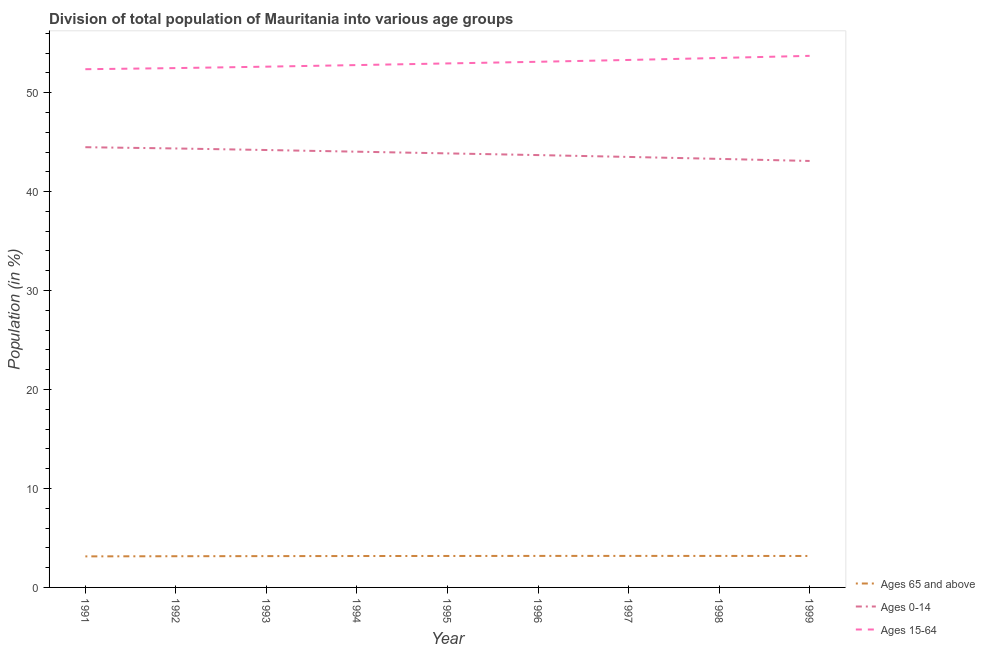Does the line corresponding to percentage of population within the age-group 0-14 intersect with the line corresponding to percentage of population within the age-group 15-64?
Offer a terse response. No. What is the percentage of population within the age-group 0-14 in 1999?
Provide a short and direct response. 43.1. Across all years, what is the maximum percentage of population within the age-group 15-64?
Your answer should be compact. 53.72. Across all years, what is the minimum percentage of population within the age-group 0-14?
Offer a very short reply. 43.1. In which year was the percentage of population within the age-group 0-14 maximum?
Provide a succinct answer. 1991. In which year was the percentage of population within the age-group of 65 and above minimum?
Provide a succinct answer. 1991. What is the total percentage of population within the age-group 15-64 in the graph?
Your answer should be compact. 476.89. What is the difference between the percentage of population within the age-group 15-64 in 1993 and that in 1995?
Give a very brief answer. -0.33. What is the difference between the percentage of population within the age-group of 65 and above in 1997 and the percentage of population within the age-group 15-64 in 1999?
Provide a succinct answer. -50.54. What is the average percentage of population within the age-group of 65 and above per year?
Offer a very short reply. 3.17. In the year 1999, what is the difference between the percentage of population within the age-group of 65 and above and percentage of population within the age-group 0-14?
Provide a succinct answer. -39.92. What is the ratio of the percentage of population within the age-group of 65 and above in 1992 to that in 1995?
Your answer should be compact. 0.99. Is the difference between the percentage of population within the age-group 15-64 in 1991 and 1992 greater than the difference between the percentage of population within the age-group 0-14 in 1991 and 1992?
Offer a very short reply. No. What is the difference between the highest and the second highest percentage of population within the age-group 15-64?
Provide a short and direct response. 0.21. What is the difference between the highest and the lowest percentage of population within the age-group of 65 and above?
Provide a short and direct response. 0.05. In how many years, is the percentage of population within the age-group of 65 and above greater than the average percentage of population within the age-group of 65 and above taken over all years?
Offer a very short reply. 6. Is the sum of the percentage of population within the age-group 0-14 in 1998 and 1999 greater than the maximum percentage of population within the age-group 15-64 across all years?
Offer a very short reply. Yes. How many lines are there?
Provide a succinct answer. 3. How many years are there in the graph?
Offer a very short reply. 9. What is the difference between two consecutive major ticks on the Y-axis?
Ensure brevity in your answer.  10. Does the graph contain grids?
Give a very brief answer. No. Where does the legend appear in the graph?
Your answer should be very brief. Bottom right. How many legend labels are there?
Your answer should be compact. 3. What is the title of the graph?
Your answer should be compact. Division of total population of Mauritania into various age groups
. What is the label or title of the X-axis?
Your response must be concise. Year. What is the label or title of the Y-axis?
Give a very brief answer. Population (in %). What is the Population (in %) in Ages 65 and above in 1991?
Provide a succinct answer. 3.14. What is the Population (in %) of Ages 0-14 in 1991?
Your answer should be compact. 44.49. What is the Population (in %) of Ages 15-64 in 1991?
Your answer should be compact. 52.37. What is the Population (in %) in Ages 65 and above in 1992?
Your answer should be very brief. 3.15. What is the Population (in %) in Ages 0-14 in 1992?
Your answer should be compact. 44.36. What is the Population (in %) of Ages 15-64 in 1992?
Provide a short and direct response. 52.48. What is the Population (in %) in Ages 65 and above in 1993?
Keep it short and to the point. 3.17. What is the Population (in %) in Ages 0-14 in 1993?
Your answer should be very brief. 44.21. What is the Population (in %) of Ages 15-64 in 1993?
Offer a very short reply. 52.63. What is the Population (in %) in Ages 65 and above in 1994?
Make the answer very short. 3.17. What is the Population (in %) in Ages 0-14 in 1994?
Keep it short and to the point. 44.04. What is the Population (in %) of Ages 15-64 in 1994?
Your response must be concise. 52.79. What is the Population (in %) in Ages 65 and above in 1995?
Give a very brief answer. 3.18. What is the Population (in %) of Ages 0-14 in 1995?
Your answer should be very brief. 43.86. What is the Population (in %) of Ages 15-64 in 1995?
Your answer should be very brief. 52.96. What is the Population (in %) in Ages 65 and above in 1996?
Offer a very short reply. 3.18. What is the Population (in %) of Ages 0-14 in 1996?
Keep it short and to the point. 43.69. What is the Population (in %) in Ages 15-64 in 1996?
Your answer should be compact. 53.12. What is the Population (in %) in Ages 65 and above in 1997?
Provide a succinct answer. 3.19. What is the Population (in %) in Ages 0-14 in 1997?
Ensure brevity in your answer.  43.51. What is the Population (in %) of Ages 15-64 in 1997?
Keep it short and to the point. 53.31. What is the Population (in %) in Ages 65 and above in 1998?
Your response must be concise. 3.18. What is the Population (in %) of Ages 0-14 in 1998?
Give a very brief answer. 43.31. What is the Population (in %) in Ages 15-64 in 1998?
Keep it short and to the point. 53.51. What is the Population (in %) of Ages 65 and above in 1999?
Provide a succinct answer. 3.18. What is the Population (in %) in Ages 0-14 in 1999?
Give a very brief answer. 43.1. What is the Population (in %) of Ages 15-64 in 1999?
Your response must be concise. 53.72. Across all years, what is the maximum Population (in %) in Ages 65 and above?
Ensure brevity in your answer.  3.19. Across all years, what is the maximum Population (in %) of Ages 0-14?
Your answer should be very brief. 44.49. Across all years, what is the maximum Population (in %) of Ages 15-64?
Make the answer very short. 53.72. Across all years, what is the minimum Population (in %) in Ages 65 and above?
Your answer should be very brief. 3.14. Across all years, what is the minimum Population (in %) in Ages 0-14?
Provide a succinct answer. 43.1. Across all years, what is the minimum Population (in %) of Ages 15-64?
Your answer should be compact. 52.37. What is the total Population (in %) of Ages 65 and above in the graph?
Keep it short and to the point. 28.54. What is the total Population (in %) of Ages 0-14 in the graph?
Offer a terse response. 394.57. What is the total Population (in %) of Ages 15-64 in the graph?
Offer a terse response. 476.89. What is the difference between the Population (in %) of Ages 65 and above in 1991 and that in 1992?
Provide a succinct answer. -0.01. What is the difference between the Population (in %) of Ages 0-14 in 1991 and that in 1992?
Provide a succinct answer. 0.13. What is the difference between the Population (in %) in Ages 15-64 in 1991 and that in 1992?
Give a very brief answer. -0.11. What is the difference between the Population (in %) of Ages 65 and above in 1991 and that in 1993?
Offer a terse response. -0.03. What is the difference between the Population (in %) of Ages 0-14 in 1991 and that in 1993?
Your answer should be very brief. 0.28. What is the difference between the Population (in %) in Ages 15-64 in 1991 and that in 1993?
Provide a succinct answer. -0.26. What is the difference between the Population (in %) of Ages 65 and above in 1991 and that in 1994?
Make the answer very short. -0.04. What is the difference between the Population (in %) of Ages 0-14 in 1991 and that in 1994?
Make the answer very short. 0.45. What is the difference between the Population (in %) of Ages 15-64 in 1991 and that in 1994?
Provide a short and direct response. -0.42. What is the difference between the Population (in %) in Ages 65 and above in 1991 and that in 1995?
Offer a very short reply. -0.04. What is the difference between the Population (in %) of Ages 0-14 in 1991 and that in 1995?
Your response must be concise. 0.63. What is the difference between the Population (in %) in Ages 15-64 in 1991 and that in 1995?
Provide a short and direct response. -0.58. What is the difference between the Population (in %) in Ages 65 and above in 1991 and that in 1996?
Offer a terse response. -0.05. What is the difference between the Population (in %) of Ages 0-14 in 1991 and that in 1996?
Your response must be concise. 0.8. What is the difference between the Population (in %) in Ages 15-64 in 1991 and that in 1996?
Give a very brief answer. -0.75. What is the difference between the Population (in %) in Ages 65 and above in 1991 and that in 1997?
Offer a terse response. -0.05. What is the difference between the Population (in %) in Ages 0-14 in 1991 and that in 1997?
Your response must be concise. 0.98. What is the difference between the Population (in %) of Ages 15-64 in 1991 and that in 1997?
Give a very brief answer. -0.94. What is the difference between the Population (in %) of Ages 65 and above in 1991 and that in 1998?
Your answer should be compact. -0.05. What is the difference between the Population (in %) in Ages 0-14 in 1991 and that in 1998?
Provide a short and direct response. 1.18. What is the difference between the Population (in %) of Ages 15-64 in 1991 and that in 1998?
Your response must be concise. -1.14. What is the difference between the Population (in %) in Ages 65 and above in 1991 and that in 1999?
Give a very brief answer. -0.04. What is the difference between the Population (in %) of Ages 0-14 in 1991 and that in 1999?
Offer a very short reply. 1.39. What is the difference between the Population (in %) of Ages 15-64 in 1991 and that in 1999?
Your answer should be compact. -1.35. What is the difference between the Population (in %) of Ages 65 and above in 1992 and that in 1993?
Provide a short and direct response. -0.01. What is the difference between the Population (in %) in Ages 0-14 in 1992 and that in 1993?
Your response must be concise. 0.16. What is the difference between the Population (in %) in Ages 15-64 in 1992 and that in 1993?
Provide a short and direct response. -0.14. What is the difference between the Population (in %) in Ages 65 and above in 1992 and that in 1994?
Your answer should be very brief. -0.02. What is the difference between the Population (in %) in Ages 0-14 in 1992 and that in 1994?
Ensure brevity in your answer.  0.33. What is the difference between the Population (in %) of Ages 15-64 in 1992 and that in 1994?
Your answer should be very brief. -0.31. What is the difference between the Population (in %) of Ages 65 and above in 1992 and that in 1995?
Ensure brevity in your answer.  -0.03. What is the difference between the Population (in %) of Ages 0-14 in 1992 and that in 1995?
Provide a succinct answer. 0.5. What is the difference between the Population (in %) of Ages 15-64 in 1992 and that in 1995?
Offer a very short reply. -0.47. What is the difference between the Population (in %) of Ages 65 and above in 1992 and that in 1996?
Give a very brief answer. -0.03. What is the difference between the Population (in %) of Ages 0-14 in 1992 and that in 1996?
Keep it short and to the point. 0.67. What is the difference between the Population (in %) in Ages 15-64 in 1992 and that in 1996?
Offer a very short reply. -0.64. What is the difference between the Population (in %) of Ages 65 and above in 1992 and that in 1997?
Keep it short and to the point. -0.03. What is the difference between the Population (in %) of Ages 0-14 in 1992 and that in 1997?
Ensure brevity in your answer.  0.86. What is the difference between the Population (in %) of Ages 15-64 in 1992 and that in 1997?
Give a very brief answer. -0.82. What is the difference between the Population (in %) in Ages 65 and above in 1992 and that in 1998?
Offer a terse response. -0.03. What is the difference between the Population (in %) in Ages 0-14 in 1992 and that in 1998?
Provide a succinct answer. 1.05. What is the difference between the Population (in %) of Ages 15-64 in 1992 and that in 1998?
Offer a very short reply. -1.02. What is the difference between the Population (in %) of Ages 65 and above in 1992 and that in 1999?
Provide a short and direct response. -0.03. What is the difference between the Population (in %) of Ages 0-14 in 1992 and that in 1999?
Your response must be concise. 1.26. What is the difference between the Population (in %) of Ages 15-64 in 1992 and that in 1999?
Keep it short and to the point. -1.24. What is the difference between the Population (in %) of Ages 65 and above in 1993 and that in 1994?
Ensure brevity in your answer.  -0.01. What is the difference between the Population (in %) in Ages 0-14 in 1993 and that in 1994?
Offer a terse response. 0.17. What is the difference between the Population (in %) of Ages 15-64 in 1993 and that in 1994?
Provide a short and direct response. -0.16. What is the difference between the Population (in %) in Ages 65 and above in 1993 and that in 1995?
Make the answer very short. -0.01. What is the difference between the Population (in %) in Ages 0-14 in 1993 and that in 1995?
Offer a very short reply. 0.34. What is the difference between the Population (in %) in Ages 15-64 in 1993 and that in 1995?
Give a very brief answer. -0.33. What is the difference between the Population (in %) of Ages 65 and above in 1993 and that in 1996?
Give a very brief answer. -0.02. What is the difference between the Population (in %) in Ages 0-14 in 1993 and that in 1996?
Keep it short and to the point. 0.51. What is the difference between the Population (in %) in Ages 15-64 in 1993 and that in 1996?
Your response must be concise. -0.49. What is the difference between the Population (in %) of Ages 65 and above in 1993 and that in 1997?
Offer a terse response. -0.02. What is the difference between the Population (in %) in Ages 0-14 in 1993 and that in 1997?
Your response must be concise. 0.7. What is the difference between the Population (in %) in Ages 15-64 in 1993 and that in 1997?
Your answer should be very brief. -0.68. What is the difference between the Population (in %) of Ages 65 and above in 1993 and that in 1998?
Offer a terse response. -0.02. What is the difference between the Population (in %) of Ages 0-14 in 1993 and that in 1998?
Your answer should be compact. 0.9. What is the difference between the Population (in %) in Ages 15-64 in 1993 and that in 1998?
Provide a succinct answer. -0.88. What is the difference between the Population (in %) in Ages 65 and above in 1993 and that in 1999?
Your response must be concise. -0.01. What is the difference between the Population (in %) in Ages 0-14 in 1993 and that in 1999?
Your answer should be compact. 1.11. What is the difference between the Population (in %) of Ages 15-64 in 1993 and that in 1999?
Offer a very short reply. -1.09. What is the difference between the Population (in %) in Ages 65 and above in 1994 and that in 1995?
Offer a terse response. -0.01. What is the difference between the Population (in %) of Ages 0-14 in 1994 and that in 1995?
Make the answer very short. 0.17. What is the difference between the Population (in %) of Ages 15-64 in 1994 and that in 1995?
Keep it short and to the point. -0.17. What is the difference between the Population (in %) in Ages 65 and above in 1994 and that in 1996?
Offer a terse response. -0.01. What is the difference between the Population (in %) of Ages 0-14 in 1994 and that in 1996?
Your answer should be compact. 0.34. What is the difference between the Population (in %) in Ages 15-64 in 1994 and that in 1996?
Give a very brief answer. -0.33. What is the difference between the Population (in %) in Ages 65 and above in 1994 and that in 1997?
Keep it short and to the point. -0.01. What is the difference between the Population (in %) of Ages 0-14 in 1994 and that in 1997?
Provide a succinct answer. 0.53. What is the difference between the Population (in %) of Ages 15-64 in 1994 and that in 1997?
Your answer should be compact. -0.52. What is the difference between the Population (in %) in Ages 65 and above in 1994 and that in 1998?
Offer a terse response. -0.01. What is the difference between the Population (in %) in Ages 0-14 in 1994 and that in 1998?
Your answer should be very brief. 0.73. What is the difference between the Population (in %) in Ages 15-64 in 1994 and that in 1998?
Offer a terse response. -0.72. What is the difference between the Population (in %) of Ages 65 and above in 1994 and that in 1999?
Offer a very short reply. -0.01. What is the difference between the Population (in %) of Ages 0-14 in 1994 and that in 1999?
Offer a terse response. 0.94. What is the difference between the Population (in %) in Ages 15-64 in 1994 and that in 1999?
Give a very brief answer. -0.93. What is the difference between the Population (in %) in Ages 65 and above in 1995 and that in 1996?
Your answer should be compact. -0.01. What is the difference between the Population (in %) in Ages 0-14 in 1995 and that in 1996?
Make the answer very short. 0.17. What is the difference between the Population (in %) in Ages 15-64 in 1995 and that in 1996?
Offer a very short reply. -0.17. What is the difference between the Population (in %) of Ages 65 and above in 1995 and that in 1997?
Your answer should be very brief. -0.01. What is the difference between the Population (in %) of Ages 0-14 in 1995 and that in 1997?
Keep it short and to the point. 0.36. What is the difference between the Population (in %) in Ages 15-64 in 1995 and that in 1997?
Offer a very short reply. -0.35. What is the difference between the Population (in %) in Ages 65 and above in 1995 and that in 1998?
Make the answer very short. -0. What is the difference between the Population (in %) in Ages 0-14 in 1995 and that in 1998?
Your answer should be very brief. 0.56. What is the difference between the Population (in %) of Ages 15-64 in 1995 and that in 1998?
Ensure brevity in your answer.  -0.55. What is the difference between the Population (in %) of Ages 65 and above in 1995 and that in 1999?
Make the answer very short. 0. What is the difference between the Population (in %) in Ages 0-14 in 1995 and that in 1999?
Your answer should be compact. 0.77. What is the difference between the Population (in %) in Ages 15-64 in 1995 and that in 1999?
Offer a very short reply. -0.77. What is the difference between the Population (in %) in Ages 65 and above in 1996 and that in 1997?
Your answer should be compact. -0. What is the difference between the Population (in %) of Ages 0-14 in 1996 and that in 1997?
Offer a very short reply. 0.19. What is the difference between the Population (in %) in Ages 15-64 in 1996 and that in 1997?
Your answer should be very brief. -0.19. What is the difference between the Population (in %) in Ages 65 and above in 1996 and that in 1998?
Your answer should be compact. 0. What is the difference between the Population (in %) of Ages 0-14 in 1996 and that in 1998?
Ensure brevity in your answer.  0.38. What is the difference between the Population (in %) in Ages 15-64 in 1996 and that in 1998?
Make the answer very short. -0.39. What is the difference between the Population (in %) in Ages 65 and above in 1996 and that in 1999?
Your response must be concise. 0.01. What is the difference between the Population (in %) in Ages 0-14 in 1996 and that in 1999?
Your answer should be compact. 0.59. What is the difference between the Population (in %) in Ages 15-64 in 1996 and that in 1999?
Your response must be concise. -0.6. What is the difference between the Population (in %) in Ages 65 and above in 1997 and that in 1998?
Your answer should be compact. 0. What is the difference between the Population (in %) of Ages 0-14 in 1997 and that in 1998?
Give a very brief answer. 0.2. What is the difference between the Population (in %) in Ages 15-64 in 1997 and that in 1998?
Offer a terse response. -0.2. What is the difference between the Population (in %) of Ages 65 and above in 1997 and that in 1999?
Give a very brief answer. 0.01. What is the difference between the Population (in %) of Ages 0-14 in 1997 and that in 1999?
Make the answer very short. 0.41. What is the difference between the Population (in %) in Ages 15-64 in 1997 and that in 1999?
Your answer should be very brief. -0.41. What is the difference between the Population (in %) in Ages 65 and above in 1998 and that in 1999?
Provide a short and direct response. 0. What is the difference between the Population (in %) in Ages 0-14 in 1998 and that in 1999?
Provide a succinct answer. 0.21. What is the difference between the Population (in %) in Ages 15-64 in 1998 and that in 1999?
Your answer should be compact. -0.21. What is the difference between the Population (in %) in Ages 65 and above in 1991 and the Population (in %) in Ages 0-14 in 1992?
Your response must be concise. -41.22. What is the difference between the Population (in %) in Ages 65 and above in 1991 and the Population (in %) in Ages 15-64 in 1992?
Make the answer very short. -49.35. What is the difference between the Population (in %) in Ages 0-14 in 1991 and the Population (in %) in Ages 15-64 in 1992?
Provide a short and direct response. -7.99. What is the difference between the Population (in %) of Ages 65 and above in 1991 and the Population (in %) of Ages 0-14 in 1993?
Offer a terse response. -41.07. What is the difference between the Population (in %) of Ages 65 and above in 1991 and the Population (in %) of Ages 15-64 in 1993?
Provide a short and direct response. -49.49. What is the difference between the Population (in %) in Ages 0-14 in 1991 and the Population (in %) in Ages 15-64 in 1993?
Your response must be concise. -8.14. What is the difference between the Population (in %) in Ages 65 and above in 1991 and the Population (in %) in Ages 0-14 in 1994?
Ensure brevity in your answer.  -40.9. What is the difference between the Population (in %) in Ages 65 and above in 1991 and the Population (in %) in Ages 15-64 in 1994?
Your answer should be compact. -49.65. What is the difference between the Population (in %) in Ages 0-14 in 1991 and the Population (in %) in Ages 15-64 in 1994?
Keep it short and to the point. -8.3. What is the difference between the Population (in %) in Ages 65 and above in 1991 and the Population (in %) in Ages 0-14 in 1995?
Ensure brevity in your answer.  -40.73. What is the difference between the Population (in %) of Ages 65 and above in 1991 and the Population (in %) of Ages 15-64 in 1995?
Offer a very short reply. -49.82. What is the difference between the Population (in %) in Ages 0-14 in 1991 and the Population (in %) in Ages 15-64 in 1995?
Provide a short and direct response. -8.47. What is the difference between the Population (in %) of Ages 65 and above in 1991 and the Population (in %) of Ages 0-14 in 1996?
Your response must be concise. -40.56. What is the difference between the Population (in %) in Ages 65 and above in 1991 and the Population (in %) in Ages 15-64 in 1996?
Give a very brief answer. -49.98. What is the difference between the Population (in %) of Ages 0-14 in 1991 and the Population (in %) of Ages 15-64 in 1996?
Make the answer very short. -8.63. What is the difference between the Population (in %) of Ages 65 and above in 1991 and the Population (in %) of Ages 0-14 in 1997?
Provide a short and direct response. -40.37. What is the difference between the Population (in %) of Ages 65 and above in 1991 and the Population (in %) of Ages 15-64 in 1997?
Ensure brevity in your answer.  -50.17. What is the difference between the Population (in %) of Ages 0-14 in 1991 and the Population (in %) of Ages 15-64 in 1997?
Offer a very short reply. -8.82. What is the difference between the Population (in %) in Ages 65 and above in 1991 and the Population (in %) in Ages 0-14 in 1998?
Your answer should be compact. -40.17. What is the difference between the Population (in %) of Ages 65 and above in 1991 and the Population (in %) of Ages 15-64 in 1998?
Give a very brief answer. -50.37. What is the difference between the Population (in %) in Ages 0-14 in 1991 and the Population (in %) in Ages 15-64 in 1998?
Offer a very short reply. -9.02. What is the difference between the Population (in %) of Ages 65 and above in 1991 and the Population (in %) of Ages 0-14 in 1999?
Your answer should be compact. -39.96. What is the difference between the Population (in %) in Ages 65 and above in 1991 and the Population (in %) in Ages 15-64 in 1999?
Keep it short and to the point. -50.58. What is the difference between the Population (in %) of Ages 0-14 in 1991 and the Population (in %) of Ages 15-64 in 1999?
Give a very brief answer. -9.23. What is the difference between the Population (in %) in Ages 65 and above in 1992 and the Population (in %) in Ages 0-14 in 1993?
Ensure brevity in your answer.  -41.05. What is the difference between the Population (in %) in Ages 65 and above in 1992 and the Population (in %) in Ages 15-64 in 1993?
Offer a very short reply. -49.48. What is the difference between the Population (in %) of Ages 0-14 in 1992 and the Population (in %) of Ages 15-64 in 1993?
Offer a very short reply. -8.27. What is the difference between the Population (in %) in Ages 65 and above in 1992 and the Population (in %) in Ages 0-14 in 1994?
Make the answer very short. -40.88. What is the difference between the Population (in %) of Ages 65 and above in 1992 and the Population (in %) of Ages 15-64 in 1994?
Your answer should be compact. -49.64. What is the difference between the Population (in %) of Ages 0-14 in 1992 and the Population (in %) of Ages 15-64 in 1994?
Your response must be concise. -8.43. What is the difference between the Population (in %) in Ages 65 and above in 1992 and the Population (in %) in Ages 0-14 in 1995?
Offer a terse response. -40.71. What is the difference between the Population (in %) in Ages 65 and above in 1992 and the Population (in %) in Ages 15-64 in 1995?
Ensure brevity in your answer.  -49.8. What is the difference between the Population (in %) of Ages 0-14 in 1992 and the Population (in %) of Ages 15-64 in 1995?
Your answer should be very brief. -8.59. What is the difference between the Population (in %) in Ages 65 and above in 1992 and the Population (in %) in Ages 0-14 in 1996?
Give a very brief answer. -40.54. What is the difference between the Population (in %) in Ages 65 and above in 1992 and the Population (in %) in Ages 15-64 in 1996?
Make the answer very short. -49.97. What is the difference between the Population (in %) of Ages 0-14 in 1992 and the Population (in %) of Ages 15-64 in 1996?
Offer a terse response. -8.76. What is the difference between the Population (in %) in Ages 65 and above in 1992 and the Population (in %) in Ages 0-14 in 1997?
Keep it short and to the point. -40.35. What is the difference between the Population (in %) of Ages 65 and above in 1992 and the Population (in %) of Ages 15-64 in 1997?
Provide a short and direct response. -50.15. What is the difference between the Population (in %) in Ages 0-14 in 1992 and the Population (in %) in Ages 15-64 in 1997?
Provide a short and direct response. -8.95. What is the difference between the Population (in %) in Ages 65 and above in 1992 and the Population (in %) in Ages 0-14 in 1998?
Ensure brevity in your answer.  -40.16. What is the difference between the Population (in %) of Ages 65 and above in 1992 and the Population (in %) of Ages 15-64 in 1998?
Give a very brief answer. -50.35. What is the difference between the Population (in %) in Ages 0-14 in 1992 and the Population (in %) in Ages 15-64 in 1998?
Make the answer very short. -9.14. What is the difference between the Population (in %) of Ages 65 and above in 1992 and the Population (in %) of Ages 0-14 in 1999?
Keep it short and to the point. -39.95. What is the difference between the Population (in %) in Ages 65 and above in 1992 and the Population (in %) in Ages 15-64 in 1999?
Offer a very short reply. -50.57. What is the difference between the Population (in %) of Ages 0-14 in 1992 and the Population (in %) of Ages 15-64 in 1999?
Your response must be concise. -9.36. What is the difference between the Population (in %) in Ages 65 and above in 1993 and the Population (in %) in Ages 0-14 in 1994?
Provide a short and direct response. -40.87. What is the difference between the Population (in %) in Ages 65 and above in 1993 and the Population (in %) in Ages 15-64 in 1994?
Make the answer very short. -49.62. What is the difference between the Population (in %) in Ages 0-14 in 1993 and the Population (in %) in Ages 15-64 in 1994?
Your answer should be very brief. -8.58. What is the difference between the Population (in %) in Ages 65 and above in 1993 and the Population (in %) in Ages 0-14 in 1995?
Your response must be concise. -40.7. What is the difference between the Population (in %) in Ages 65 and above in 1993 and the Population (in %) in Ages 15-64 in 1995?
Your answer should be compact. -49.79. What is the difference between the Population (in %) of Ages 0-14 in 1993 and the Population (in %) of Ages 15-64 in 1995?
Keep it short and to the point. -8.75. What is the difference between the Population (in %) in Ages 65 and above in 1993 and the Population (in %) in Ages 0-14 in 1996?
Offer a very short reply. -40.53. What is the difference between the Population (in %) of Ages 65 and above in 1993 and the Population (in %) of Ages 15-64 in 1996?
Provide a succinct answer. -49.96. What is the difference between the Population (in %) of Ages 0-14 in 1993 and the Population (in %) of Ages 15-64 in 1996?
Keep it short and to the point. -8.92. What is the difference between the Population (in %) in Ages 65 and above in 1993 and the Population (in %) in Ages 0-14 in 1997?
Ensure brevity in your answer.  -40.34. What is the difference between the Population (in %) of Ages 65 and above in 1993 and the Population (in %) of Ages 15-64 in 1997?
Offer a terse response. -50.14. What is the difference between the Population (in %) of Ages 0-14 in 1993 and the Population (in %) of Ages 15-64 in 1997?
Make the answer very short. -9.1. What is the difference between the Population (in %) of Ages 65 and above in 1993 and the Population (in %) of Ages 0-14 in 1998?
Offer a very short reply. -40.14. What is the difference between the Population (in %) in Ages 65 and above in 1993 and the Population (in %) in Ages 15-64 in 1998?
Offer a terse response. -50.34. What is the difference between the Population (in %) in Ages 0-14 in 1993 and the Population (in %) in Ages 15-64 in 1998?
Provide a short and direct response. -9.3. What is the difference between the Population (in %) in Ages 65 and above in 1993 and the Population (in %) in Ages 0-14 in 1999?
Your response must be concise. -39.93. What is the difference between the Population (in %) of Ages 65 and above in 1993 and the Population (in %) of Ages 15-64 in 1999?
Give a very brief answer. -50.56. What is the difference between the Population (in %) in Ages 0-14 in 1993 and the Population (in %) in Ages 15-64 in 1999?
Offer a very short reply. -9.52. What is the difference between the Population (in %) in Ages 65 and above in 1994 and the Population (in %) in Ages 0-14 in 1995?
Offer a very short reply. -40.69. What is the difference between the Population (in %) of Ages 65 and above in 1994 and the Population (in %) of Ages 15-64 in 1995?
Ensure brevity in your answer.  -49.78. What is the difference between the Population (in %) in Ages 0-14 in 1994 and the Population (in %) in Ages 15-64 in 1995?
Your answer should be very brief. -8.92. What is the difference between the Population (in %) of Ages 65 and above in 1994 and the Population (in %) of Ages 0-14 in 1996?
Your answer should be very brief. -40.52. What is the difference between the Population (in %) of Ages 65 and above in 1994 and the Population (in %) of Ages 15-64 in 1996?
Give a very brief answer. -49.95. What is the difference between the Population (in %) of Ages 0-14 in 1994 and the Population (in %) of Ages 15-64 in 1996?
Ensure brevity in your answer.  -9.09. What is the difference between the Population (in %) in Ages 65 and above in 1994 and the Population (in %) in Ages 0-14 in 1997?
Provide a short and direct response. -40.33. What is the difference between the Population (in %) in Ages 65 and above in 1994 and the Population (in %) in Ages 15-64 in 1997?
Make the answer very short. -50.13. What is the difference between the Population (in %) of Ages 0-14 in 1994 and the Population (in %) of Ages 15-64 in 1997?
Keep it short and to the point. -9.27. What is the difference between the Population (in %) of Ages 65 and above in 1994 and the Population (in %) of Ages 0-14 in 1998?
Ensure brevity in your answer.  -40.14. What is the difference between the Population (in %) in Ages 65 and above in 1994 and the Population (in %) in Ages 15-64 in 1998?
Your response must be concise. -50.33. What is the difference between the Population (in %) of Ages 0-14 in 1994 and the Population (in %) of Ages 15-64 in 1998?
Provide a short and direct response. -9.47. What is the difference between the Population (in %) in Ages 65 and above in 1994 and the Population (in %) in Ages 0-14 in 1999?
Make the answer very short. -39.93. What is the difference between the Population (in %) of Ages 65 and above in 1994 and the Population (in %) of Ages 15-64 in 1999?
Your answer should be very brief. -50.55. What is the difference between the Population (in %) of Ages 0-14 in 1994 and the Population (in %) of Ages 15-64 in 1999?
Give a very brief answer. -9.69. What is the difference between the Population (in %) of Ages 65 and above in 1995 and the Population (in %) of Ages 0-14 in 1996?
Provide a succinct answer. -40.51. What is the difference between the Population (in %) in Ages 65 and above in 1995 and the Population (in %) in Ages 15-64 in 1996?
Your answer should be compact. -49.94. What is the difference between the Population (in %) of Ages 0-14 in 1995 and the Population (in %) of Ages 15-64 in 1996?
Your answer should be compact. -9.26. What is the difference between the Population (in %) of Ages 65 and above in 1995 and the Population (in %) of Ages 0-14 in 1997?
Provide a succinct answer. -40.33. What is the difference between the Population (in %) of Ages 65 and above in 1995 and the Population (in %) of Ages 15-64 in 1997?
Make the answer very short. -50.13. What is the difference between the Population (in %) in Ages 0-14 in 1995 and the Population (in %) in Ages 15-64 in 1997?
Ensure brevity in your answer.  -9.44. What is the difference between the Population (in %) in Ages 65 and above in 1995 and the Population (in %) in Ages 0-14 in 1998?
Provide a succinct answer. -40.13. What is the difference between the Population (in %) in Ages 65 and above in 1995 and the Population (in %) in Ages 15-64 in 1998?
Provide a short and direct response. -50.33. What is the difference between the Population (in %) of Ages 0-14 in 1995 and the Population (in %) of Ages 15-64 in 1998?
Give a very brief answer. -9.64. What is the difference between the Population (in %) of Ages 65 and above in 1995 and the Population (in %) of Ages 0-14 in 1999?
Offer a very short reply. -39.92. What is the difference between the Population (in %) of Ages 65 and above in 1995 and the Population (in %) of Ages 15-64 in 1999?
Ensure brevity in your answer.  -50.54. What is the difference between the Population (in %) in Ages 0-14 in 1995 and the Population (in %) in Ages 15-64 in 1999?
Your answer should be compact. -9.86. What is the difference between the Population (in %) of Ages 65 and above in 1996 and the Population (in %) of Ages 0-14 in 1997?
Give a very brief answer. -40.32. What is the difference between the Population (in %) in Ages 65 and above in 1996 and the Population (in %) in Ages 15-64 in 1997?
Your answer should be very brief. -50.12. What is the difference between the Population (in %) in Ages 0-14 in 1996 and the Population (in %) in Ages 15-64 in 1997?
Provide a succinct answer. -9.61. What is the difference between the Population (in %) of Ages 65 and above in 1996 and the Population (in %) of Ages 0-14 in 1998?
Your answer should be very brief. -40.12. What is the difference between the Population (in %) in Ages 65 and above in 1996 and the Population (in %) in Ages 15-64 in 1998?
Give a very brief answer. -50.32. What is the difference between the Population (in %) in Ages 0-14 in 1996 and the Population (in %) in Ages 15-64 in 1998?
Offer a terse response. -9.81. What is the difference between the Population (in %) in Ages 65 and above in 1996 and the Population (in %) in Ages 0-14 in 1999?
Provide a short and direct response. -39.91. What is the difference between the Population (in %) of Ages 65 and above in 1996 and the Population (in %) of Ages 15-64 in 1999?
Provide a succinct answer. -50.54. What is the difference between the Population (in %) in Ages 0-14 in 1996 and the Population (in %) in Ages 15-64 in 1999?
Provide a succinct answer. -10.03. What is the difference between the Population (in %) in Ages 65 and above in 1997 and the Population (in %) in Ages 0-14 in 1998?
Your answer should be compact. -40.12. What is the difference between the Population (in %) in Ages 65 and above in 1997 and the Population (in %) in Ages 15-64 in 1998?
Give a very brief answer. -50.32. What is the difference between the Population (in %) of Ages 0-14 in 1997 and the Population (in %) of Ages 15-64 in 1998?
Your answer should be compact. -10. What is the difference between the Population (in %) in Ages 65 and above in 1997 and the Population (in %) in Ages 0-14 in 1999?
Provide a short and direct response. -39.91. What is the difference between the Population (in %) of Ages 65 and above in 1997 and the Population (in %) of Ages 15-64 in 1999?
Give a very brief answer. -50.54. What is the difference between the Population (in %) in Ages 0-14 in 1997 and the Population (in %) in Ages 15-64 in 1999?
Offer a very short reply. -10.21. What is the difference between the Population (in %) of Ages 65 and above in 1998 and the Population (in %) of Ages 0-14 in 1999?
Offer a terse response. -39.92. What is the difference between the Population (in %) of Ages 65 and above in 1998 and the Population (in %) of Ages 15-64 in 1999?
Your answer should be very brief. -50.54. What is the difference between the Population (in %) in Ages 0-14 in 1998 and the Population (in %) in Ages 15-64 in 1999?
Your answer should be very brief. -10.41. What is the average Population (in %) in Ages 65 and above per year?
Your answer should be very brief. 3.17. What is the average Population (in %) of Ages 0-14 per year?
Your response must be concise. 43.84. What is the average Population (in %) of Ages 15-64 per year?
Make the answer very short. 52.99. In the year 1991, what is the difference between the Population (in %) in Ages 65 and above and Population (in %) in Ages 0-14?
Provide a succinct answer. -41.35. In the year 1991, what is the difference between the Population (in %) in Ages 65 and above and Population (in %) in Ages 15-64?
Give a very brief answer. -49.23. In the year 1991, what is the difference between the Population (in %) in Ages 0-14 and Population (in %) in Ages 15-64?
Make the answer very short. -7.88. In the year 1992, what is the difference between the Population (in %) of Ages 65 and above and Population (in %) of Ages 0-14?
Offer a terse response. -41.21. In the year 1992, what is the difference between the Population (in %) in Ages 65 and above and Population (in %) in Ages 15-64?
Your answer should be very brief. -49.33. In the year 1992, what is the difference between the Population (in %) of Ages 0-14 and Population (in %) of Ages 15-64?
Your answer should be compact. -8.12. In the year 1993, what is the difference between the Population (in %) in Ages 65 and above and Population (in %) in Ages 0-14?
Give a very brief answer. -41.04. In the year 1993, what is the difference between the Population (in %) of Ages 65 and above and Population (in %) of Ages 15-64?
Make the answer very short. -49.46. In the year 1993, what is the difference between the Population (in %) in Ages 0-14 and Population (in %) in Ages 15-64?
Give a very brief answer. -8.42. In the year 1994, what is the difference between the Population (in %) in Ages 65 and above and Population (in %) in Ages 0-14?
Make the answer very short. -40.86. In the year 1994, what is the difference between the Population (in %) of Ages 65 and above and Population (in %) of Ages 15-64?
Provide a short and direct response. -49.62. In the year 1994, what is the difference between the Population (in %) in Ages 0-14 and Population (in %) in Ages 15-64?
Offer a terse response. -8.75. In the year 1995, what is the difference between the Population (in %) of Ages 65 and above and Population (in %) of Ages 0-14?
Ensure brevity in your answer.  -40.69. In the year 1995, what is the difference between the Population (in %) of Ages 65 and above and Population (in %) of Ages 15-64?
Keep it short and to the point. -49.78. In the year 1995, what is the difference between the Population (in %) in Ages 0-14 and Population (in %) in Ages 15-64?
Offer a very short reply. -9.09. In the year 1996, what is the difference between the Population (in %) of Ages 65 and above and Population (in %) of Ages 0-14?
Offer a terse response. -40.51. In the year 1996, what is the difference between the Population (in %) of Ages 65 and above and Population (in %) of Ages 15-64?
Offer a terse response. -49.94. In the year 1996, what is the difference between the Population (in %) in Ages 0-14 and Population (in %) in Ages 15-64?
Your response must be concise. -9.43. In the year 1997, what is the difference between the Population (in %) in Ages 65 and above and Population (in %) in Ages 0-14?
Keep it short and to the point. -40.32. In the year 1997, what is the difference between the Population (in %) in Ages 65 and above and Population (in %) in Ages 15-64?
Offer a terse response. -50.12. In the year 1997, what is the difference between the Population (in %) in Ages 0-14 and Population (in %) in Ages 15-64?
Your response must be concise. -9.8. In the year 1998, what is the difference between the Population (in %) in Ages 65 and above and Population (in %) in Ages 0-14?
Offer a very short reply. -40.13. In the year 1998, what is the difference between the Population (in %) of Ages 65 and above and Population (in %) of Ages 15-64?
Your answer should be very brief. -50.32. In the year 1998, what is the difference between the Population (in %) in Ages 0-14 and Population (in %) in Ages 15-64?
Your answer should be very brief. -10.2. In the year 1999, what is the difference between the Population (in %) in Ages 65 and above and Population (in %) in Ages 0-14?
Provide a succinct answer. -39.92. In the year 1999, what is the difference between the Population (in %) in Ages 65 and above and Population (in %) in Ages 15-64?
Provide a short and direct response. -50.54. In the year 1999, what is the difference between the Population (in %) in Ages 0-14 and Population (in %) in Ages 15-64?
Offer a very short reply. -10.62. What is the ratio of the Population (in %) of Ages 0-14 in 1991 to that in 1992?
Your answer should be very brief. 1. What is the ratio of the Population (in %) of Ages 0-14 in 1991 to that in 1993?
Your answer should be very brief. 1.01. What is the ratio of the Population (in %) of Ages 65 and above in 1991 to that in 1994?
Your answer should be very brief. 0.99. What is the ratio of the Population (in %) in Ages 0-14 in 1991 to that in 1994?
Offer a very short reply. 1.01. What is the ratio of the Population (in %) in Ages 15-64 in 1991 to that in 1994?
Your answer should be very brief. 0.99. What is the ratio of the Population (in %) of Ages 65 and above in 1991 to that in 1995?
Offer a very short reply. 0.99. What is the ratio of the Population (in %) of Ages 0-14 in 1991 to that in 1995?
Make the answer very short. 1.01. What is the ratio of the Population (in %) of Ages 65 and above in 1991 to that in 1996?
Give a very brief answer. 0.99. What is the ratio of the Population (in %) of Ages 0-14 in 1991 to that in 1996?
Ensure brevity in your answer.  1.02. What is the ratio of the Population (in %) in Ages 15-64 in 1991 to that in 1996?
Keep it short and to the point. 0.99. What is the ratio of the Population (in %) in Ages 65 and above in 1991 to that in 1997?
Offer a very short reply. 0.99. What is the ratio of the Population (in %) of Ages 0-14 in 1991 to that in 1997?
Your answer should be compact. 1.02. What is the ratio of the Population (in %) of Ages 15-64 in 1991 to that in 1997?
Your response must be concise. 0.98. What is the ratio of the Population (in %) in Ages 65 and above in 1991 to that in 1998?
Your answer should be compact. 0.99. What is the ratio of the Population (in %) in Ages 0-14 in 1991 to that in 1998?
Provide a short and direct response. 1.03. What is the ratio of the Population (in %) of Ages 15-64 in 1991 to that in 1998?
Give a very brief answer. 0.98. What is the ratio of the Population (in %) in Ages 65 and above in 1991 to that in 1999?
Your response must be concise. 0.99. What is the ratio of the Population (in %) in Ages 0-14 in 1991 to that in 1999?
Offer a very short reply. 1.03. What is the ratio of the Population (in %) of Ages 15-64 in 1991 to that in 1999?
Your answer should be compact. 0.97. What is the ratio of the Population (in %) of Ages 65 and above in 1992 to that in 1993?
Keep it short and to the point. 1. What is the ratio of the Population (in %) in Ages 0-14 in 1992 to that in 1994?
Make the answer very short. 1.01. What is the ratio of the Population (in %) of Ages 0-14 in 1992 to that in 1995?
Make the answer very short. 1.01. What is the ratio of the Population (in %) in Ages 65 and above in 1992 to that in 1996?
Keep it short and to the point. 0.99. What is the ratio of the Population (in %) of Ages 0-14 in 1992 to that in 1996?
Offer a very short reply. 1.02. What is the ratio of the Population (in %) in Ages 15-64 in 1992 to that in 1996?
Provide a short and direct response. 0.99. What is the ratio of the Population (in %) of Ages 0-14 in 1992 to that in 1997?
Give a very brief answer. 1.02. What is the ratio of the Population (in %) in Ages 15-64 in 1992 to that in 1997?
Your answer should be very brief. 0.98. What is the ratio of the Population (in %) in Ages 65 and above in 1992 to that in 1998?
Offer a very short reply. 0.99. What is the ratio of the Population (in %) of Ages 0-14 in 1992 to that in 1998?
Your answer should be very brief. 1.02. What is the ratio of the Population (in %) of Ages 15-64 in 1992 to that in 1998?
Keep it short and to the point. 0.98. What is the ratio of the Population (in %) of Ages 0-14 in 1992 to that in 1999?
Your response must be concise. 1.03. What is the ratio of the Population (in %) of Ages 65 and above in 1993 to that in 1994?
Keep it short and to the point. 1. What is the ratio of the Population (in %) in Ages 0-14 in 1993 to that in 1994?
Provide a short and direct response. 1. What is the ratio of the Population (in %) in Ages 15-64 in 1993 to that in 1994?
Your response must be concise. 1. What is the ratio of the Population (in %) of Ages 65 and above in 1993 to that in 1995?
Your answer should be compact. 1. What is the ratio of the Population (in %) in Ages 65 and above in 1993 to that in 1996?
Make the answer very short. 0.99. What is the ratio of the Population (in %) in Ages 0-14 in 1993 to that in 1996?
Give a very brief answer. 1.01. What is the ratio of the Population (in %) in Ages 65 and above in 1993 to that in 1997?
Keep it short and to the point. 0.99. What is the ratio of the Population (in %) in Ages 0-14 in 1993 to that in 1997?
Your answer should be very brief. 1.02. What is the ratio of the Population (in %) of Ages 15-64 in 1993 to that in 1997?
Provide a succinct answer. 0.99. What is the ratio of the Population (in %) of Ages 0-14 in 1993 to that in 1998?
Ensure brevity in your answer.  1.02. What is the ratio of the Population (in %) of Ages 15-64 in 1993 to that in 1998?
Provide a short and direct response. 0.98. What is the ratio of the Population (in %) of Ages 65 and above in 1993 to that in 1999?
Provide a succinct answer. 1. What is the ratio of the Population (in %) in Ages 0-14 in 1993 to that in 1999?
Offer a terse response. 1.03. What is the ratio of the Population (in %) in Ages 15-64 in 1993 to that in 1999?
Offer a terse response. 0.98. What is the ratio of the Population (in %) of Ages 65 and above in 1994 to that in 1995?
Provide a succinct answer. 1. What is the ratio of the Population (in %) of Ages 0-14 in 1994 to that in 1996?
Offer a very short reply. 1.01. What is the ratio of the Population (in %) of Ages 0-14 in 1994 to that in 1997?
Offer a very short reply. 1.01. What is the ratio of the Population (in %) of Ages 15-64 in 1994 to that in 1997?
Ensure brevity in your answer.  0.99. What is the ratio of the Population (in %) of Ages 0-14 in 1994 to that in 1998?
Your answer should be very brief. 1.02. What is the ratio of the Population (in %) of Ages 15-64 in 1994 to that in 1998?
Offer a terse response. 0.99. What is the ratio of the Population (in %) of Ages 65 and above in 1994 to that in 1999?
Your response must be concise. 1. What is the ratio of the Population (in %) of Ages 0-14 in 1994 to that in 1999?
Offer a terse response. 1.02. What is the ratio of the Population (in %) of Ages 15-64 in 1994 to that in 1999?
Your answer should be very brief. 0.98. What is the ratio of the Population (in %) of Ages 65 and above in 1995 to that in 1996?
Ensure brevity in your answer.  1. What is the ratio of the Population (in %) of Ages 0-14 in 1995 to that in 1996?
Ensure brevity in your answer.  1. What is the ratio of the Population (in %) of Ages 15-64 in 1995 to that in 1996?
Your answer should be very brief. 1. What is the ratio of the Population (in %) of Ages 0-14 in 1995 to that in 1997?
Provide a succinct answer. 1.01. What is the ratio of the Population (in %) of Ages 15-64 in 1995 to that in 1997?
Your response must be concise. 0.99. What is the ratio of the Population (in %) in Ages 0-14 in 1995 to that in 1998?
Your answer should be compact. 1.01. What is the ratio of the Population (in %) of Ages 65 and above in 1995 to that in 1999?
Give a very brief answer. 1. What is the ratio of the Population (in %) of Ages 0-14 in 1995 to that in 1999?
Offer a very short reply. 1.02. What is the ratio of the Population (in %) in Ages 15-64 in 1995 to that in 1999?
Your answer should be compact. 0.99. What is the ratio of the Population (in %) in Ages 0-14 in 1996 to that in 1998?
Provide a short and direct response. 1.01. What is the ratio of the Population (in %) in Ages 15-64 in 1996 to that in 1998?
Provide a succinct answer. 0.99. What is the ratio of the Population (in %) in Ages 0-14 in 1996 to that in 1999?
Your answer should be very brief. 1.01. What is the ratio of the Population (in %) of Ages 15-64 in 1996 to that in 1999?
Give a very brief answer. 0.99. What is the ratio of the Population (in %) of Ages 15-64 in 1997 to that in 1998?
Provide a short and direct response. 1. What is the ratio of the Population (in %) of Ages 65 and above in 1997 to that in 1999?
Your response must be concise. 1. What is the ratio of the Population (in %) in Ages 0-14 in 1997 to that in 1999?
Your answer should be very brief. 1.01. What is the ratio of the Population (in %) in Ages 65 and above in 1998 to that in 1999?
Offer a very short reply. 1. What is the ratio of the Population (in %) of Ages 0-14 in 1998 to that in 1999?
Your answer should be compact. 1. What is the difference between the highest and the second highest Population (in %) of Ages 65 and above?
Provide a short and direct response. 0. What is the difference between the highest and the second highest Population (in %) in Ages 0-14?
Your answer should be compact. 0.13. What is the difference between the highest and the second highest Population (in %) of Ages 15-64?
Offer a very short reply. 0.21. What is the difference between the highest and the lowest Population (in %) in Ages 65 and above?
Ensure brevity in your answer.  0.05. What is the difference between the highest and the lowest Population (in %) in Ages 0-14?
Your answer should be compact. 1.39. What is the difference between the highest and the lowest Population (in %) in Ages 15-64?
Give a very brief answer. 1.35. 